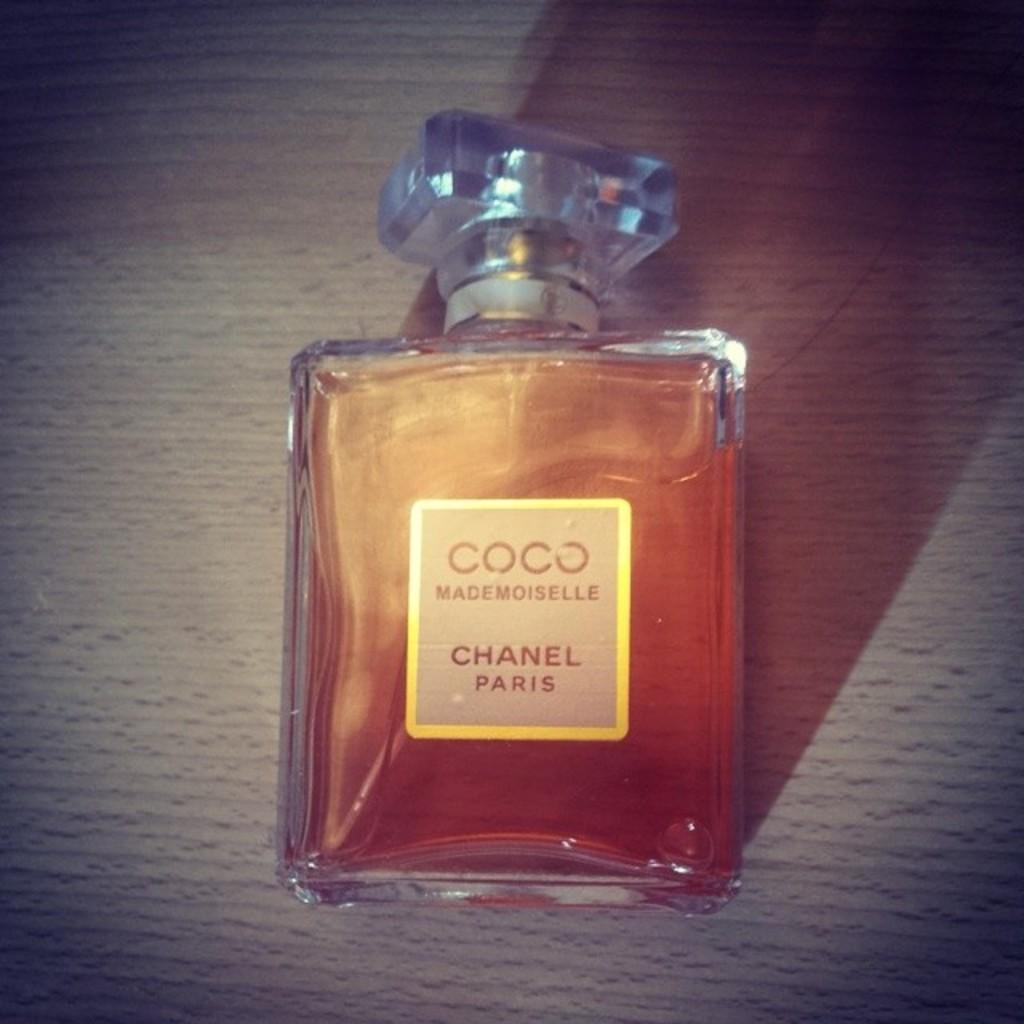What object can be seen in the image? There is a bottle in the image. Where is the bottle located? The bottle is present on a table. What type of oil can be seen in the waves near the bottle in the image? There is no oil or waves present in the image; it only features a bottle on a table. 